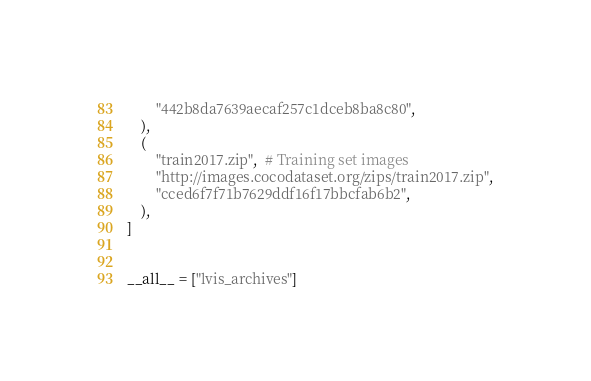<code> <loc_0><loc_0><loc_500><loc_500><_Python_>        "442b8da7639aecaf257c1dceb8ba8c80",
    ),
    (
        "train2017.zip",  # Training set images
        "http://images.cocodataset.org/zips/train2017.zip",
        "cced6f7f71b7629ddf16f17bbcfab6b2",
    ),
]


__all__ = ["lvis_archives"]
</code> 